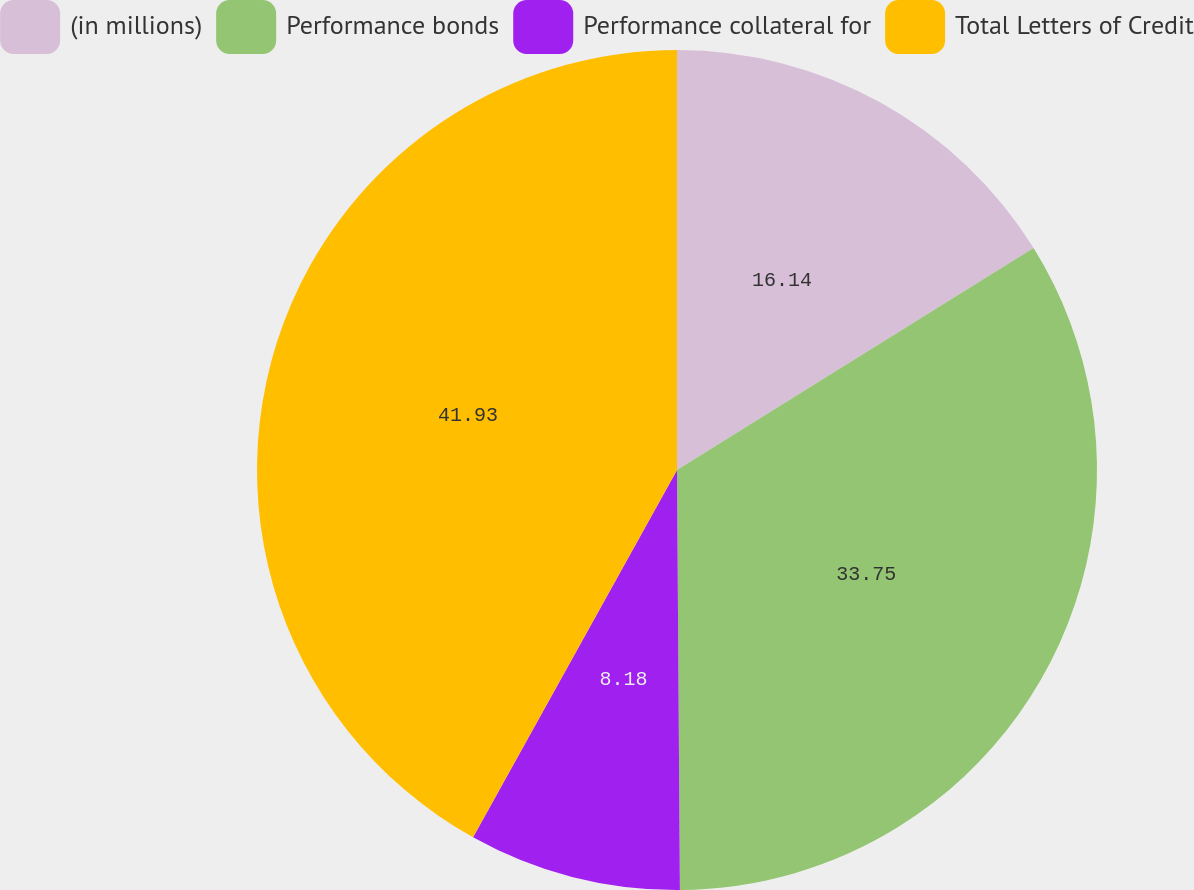Convert chart to OTSL. <chart><loc_0><loc_0><loc_500><loc_500><pie_chart><fcel>(in millions)<fcel>Performance bonds<fcel>Performance collateral for<fcel>Total Letters of Credit<nl><fcel>16.14%<fcel>33.75%<fcel>8.18%<fcel>41.93%<nl></chart> 